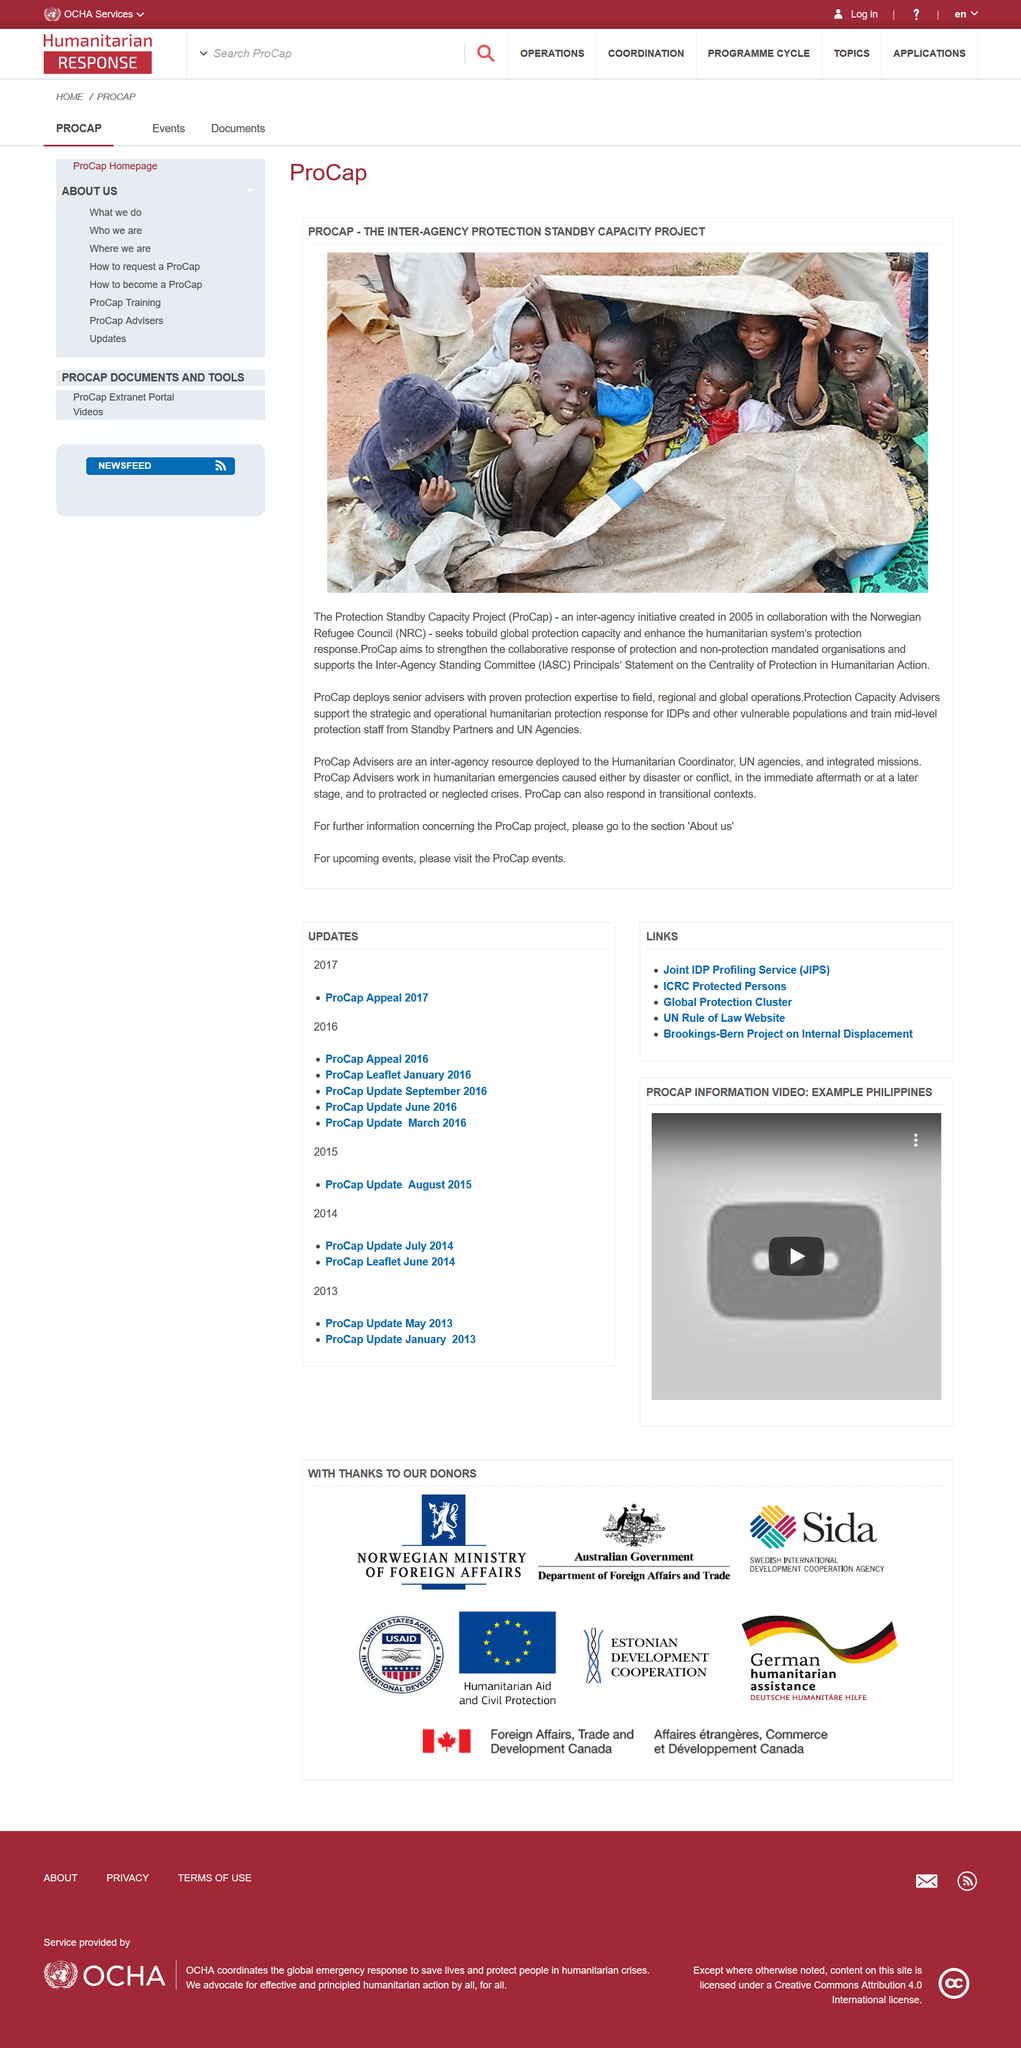List a handful of essential elements in this visual. ProCap Advisers work in various situations, including field, regional, and global operations, humanitarian emergencies, transitional contexts, and other crises. ProCap collaborated with the Norwegian Refugee Council upon its creation to provide aid and support to refugees in need. The Protection Standby Capacity Project was created in 2005. It was created in 2005. 